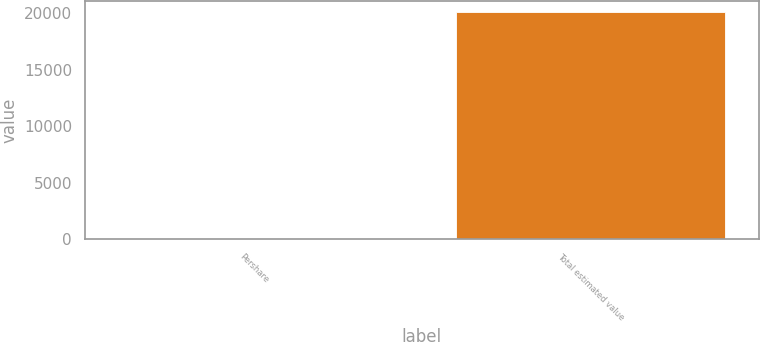Convert chart. <chart><loc_0><loc_0><loc_500><loc_500><bar_chart><fcel>Pershare<fcel>Total estimated value<nl><fcel>7.63<fcel>20074<nl></chart> 